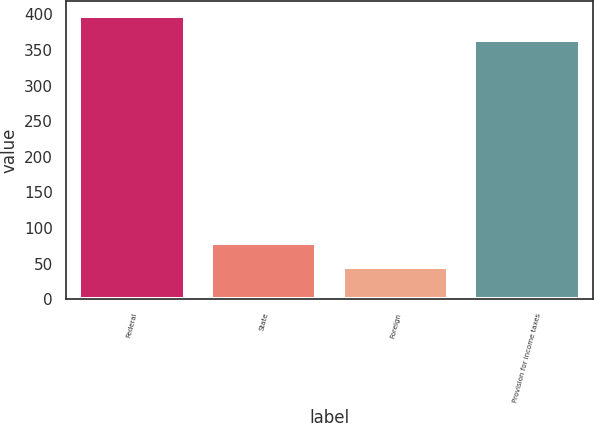Convert chart. <chart><loc_0><loc_0><loc_500><loc_500><bar_chart><fcel>Federal<fcel>State<fcel>Foreign<fcel>Provision for income taxes<nl><fcel>398.4<fcel>79.4<fcel>45<fcel>364<nl></chart> 